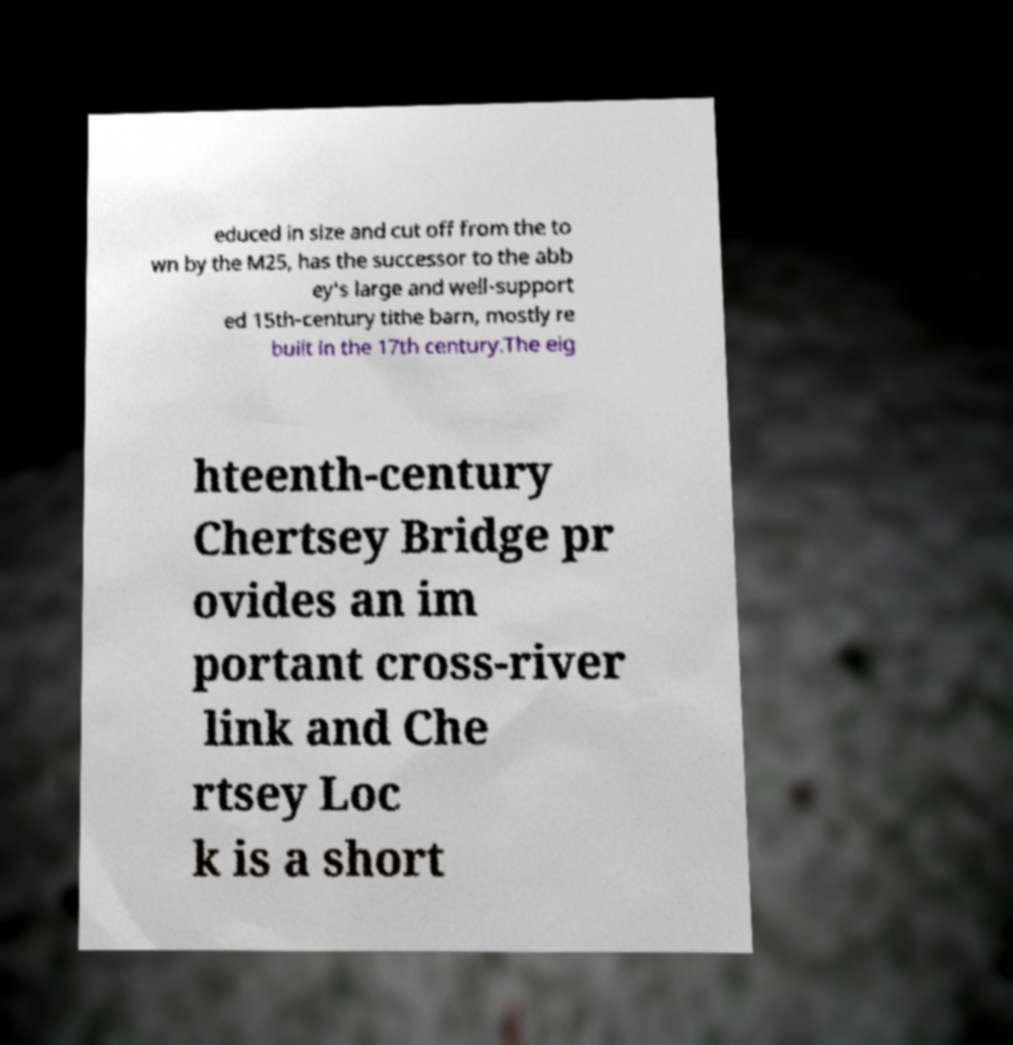For documentation purposes, I need the text within this image transcribed. Could you provide that? educed in size and cut off from the to wn by the M25, has the successor to the abb ey's large and well-support ed 15th-century tithe barn, mostly re built in the 17th century.The eig hteenth-century Chertsey Bridge pr ovides an im portant cross-river link and Che rtsey Loc k is a short 